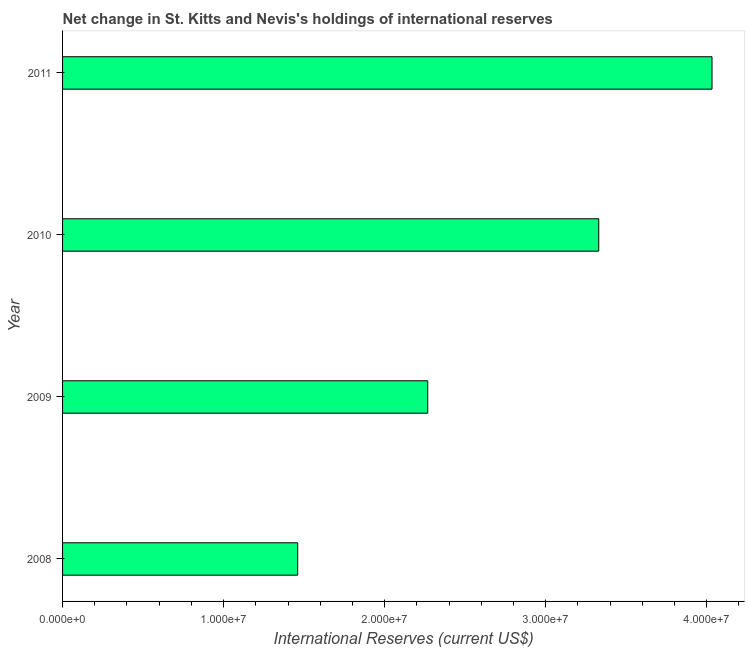Does the graph contain any zero values?
Give a very brief answer. No. What is the title of the graph?
Keep it short and to the point. Net change in St. Kitts and Nevis's holdings of international reserves. What is the label or title of the X-axis?
Your response must be concise. International Reserves (current US$). What is the reserves and related items in 2008?
Your response must be concise. 1.46e+07. Across all years, what is the maximum reserves and related items?
Your answer should be compact. 4.03e+07. Across all years, what is the minimum reserves and related items?
Your answer should be very brief. 1.46e+07. In which year was the reserves and related items maximum?
Your answer should be compact. 2011. In which year was the reserves and related items minimum?
Offer a very short reply. 2008. What is the sum of the reserves and related items?
Your response must be concise. 1.11e+08. What is the difference between the reserves and related items in 2008 and 2010?
Your answer should be compact. -1.87e+07. What is the average reserves and related items per year?
Ensure brevity in your answer.  2.77e+07. What is the median reserves and related items?
Keep it short and to the point. 2.80e+07. What is the ratio of the reserves and related items in 2009 to that in 2011?
Ensure brevity in your answer.  0.56. Is the reserves and related items in 2010 less than that in 2011?
Your answer should be very brief. Yes. Is the difference between the reserves and related items in 2008 and 2009 greater than the difference between any two years?
Offer a terse response. No. What is the difference between the highest and the second highest reserves and related items?
Give a very brief answer. 7.03e+06. Is the sum of the reserves and related items in 2009 and 2011 greater than the maximum reserves and related items across all years?
Provide a short and direct response. Yes. What is the difference between the highest and the lowest reserves and related items?
Give a very brief answer. 2.57e+07. Are all the bars in the graph horizontal?
Offer a terse response. Yes. How many years are there in the graph?
Ensure brevity in your answer.  4. What is the difference between two consecutive major ticks on the X-axis?
Provide a short and direct response. 1.00e+07. What is the International Reserves (current US$) of 2008?
Offer a very short reply. 1.46e+07. What is the International Reserves (current US$) in 2009?
Give a very brief answer. 2.27e+07. What is the International Reserves (current US$) of 2010?
Provide a short and direct response. 3.33e+07. What is the International Reserves (current US$) of 2011?
Provide a short and direct response. 4.03e+07. What is the difference between the International Reserves (current US$) in 2008 and 2009?
Your answer should be very brief. -8.07e+06. What is the difference between the International Reserves (current US$) in 2008 and 2010?
Your answer should be compact. -1.87e+07. What is the difference between the International Reserves (current US$) in 2008 and 2011?
Offer a very short reply. -2.57e+07. What is the difference between the International Reserves (current US$) in 2009 and 2010?
Make the answer very short. -1.06e+07. What is the difference between the International Reserves (current US$) in 2009 and 2011?
Your answer should be very brief. -1.77e+07. What is the difference between the International Reserves (current US$) in 2010 and 2011?
Your response must be concise. -7.03e+06. What is the ratio of the International Reserves (current US$) in 2008 to that in 2009?
Keep it short and to the point. 0.64. What is the ratio of the International Reserves (current US$) in 2008 to that in 2010?
Your response must be concise. 0.44. What is the ratio of the International Reserves (current US$) in 2008 to that in 2011?
Keep it short and to the point. 0.36. What is the ratio of the International Reserves (current US$) in 2009 to that in 2010?
Offer a very short reply. 0.68. What is the ratio of the International Reserves (current US$) in 2009 to that in 2011?
Offer a very short reply. 0.56. What is the ratio of the International Reserves (current US$) in 2010 to that in 2011?
Your response must be concise. 0.83. 